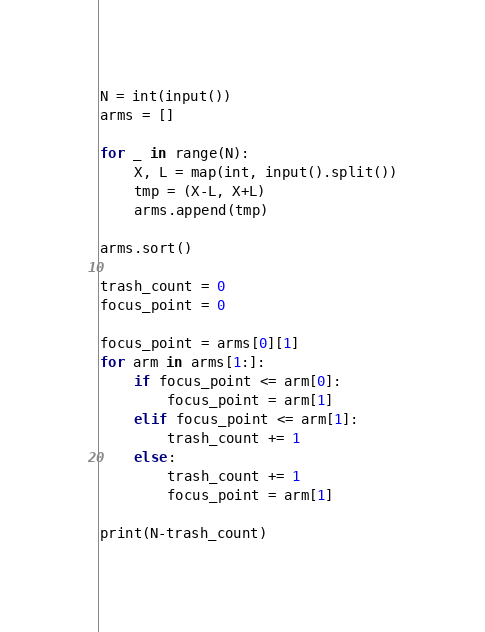<code> <loc_0><loc_0><loc_500><loc_500><_Python_>N = int(input())
arms = []

for _ in range(N):
    X, L = map(int, input().split())
    tmp = (X-L, X+L)
    arms.append(tmp)

arms.sort()

trash_count = 0
focus_point = 0

focus_point = arms[0][1]
for arm in arms[1:]:
    if focus_point <= arm[0]:
        focus_point = arm[1]
    elif focus_point <= arm[1]:
        trash_count += 1
    else:
        trash_count += 1
        focus_point = arm[1]

print(N-trash_count)
</code> 